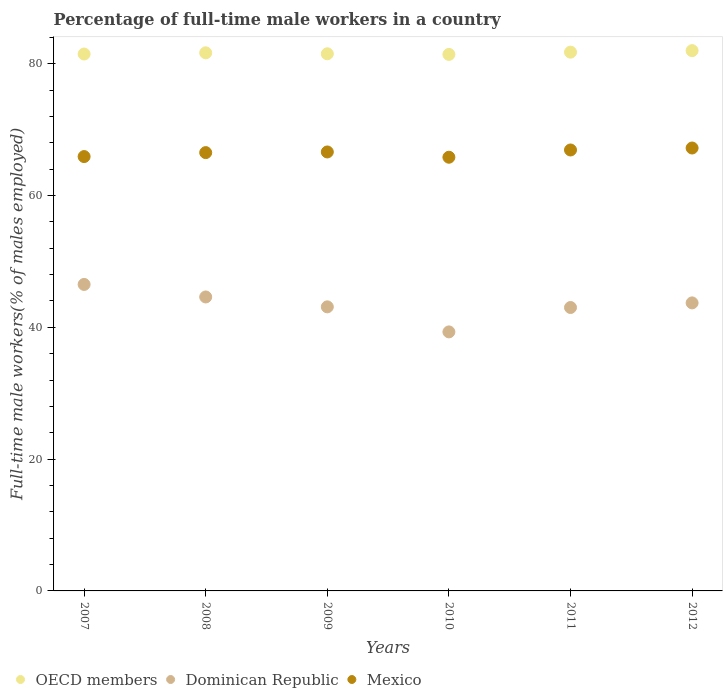How many different coloured dotlines are there?
Your response must be concise. 3. Across all years, what is the maximum percentage of full-time male workers in OECD members?
Offer a terse response. 81.97. Across all years, what is the minimum percentage of full-time male workers in Dominican Republic?
Provide a succinct answer. 39.3. What is the total percentage of full-time male workers in OECD members in the graph?
Give a very brief answer. 489.71. What is the difference between the percentage of full-time male workers in OECD members in 2008 and that in 2009?
Make the answer very short. 0.15. What is the difference between the percentage of full-time male workers in Mexico in 2008 and the percentage of full-time male workers in Dominican Republic in 2012?
Offer a terse response. 22.8. What is the average percentage of full-time male workers in Mexico per year?
Ensure brevity in your answer.  66.48. In the year 2008, what is the difference between the percentage of full-time male workers in Mexico and percentage of full-time male workers in Dominican Republic?
Ensure brevity in your answer.  21.9. What is the ratio of the percentage of full-time male workers in OECD members in 2008 to that in 2009?
Offer a terse response. 1. Is the percentage of full-time male workers in Mexico in 2009 less than that in 2010?
Keep it short and to the point. No. Is the difference between the percentage of full-time male workers in Mexico in 2007 and 2012 greater than the difference between the percentage of full-time male workers in Dominican Republic in 2007 and 2012?
Provide a short and direct response. No. What is the difference between the highest and the second highest percentage of full-time male workers in Dominican Republic?
Make the answer very short. 1.9. What is the difference between the highest and the lowest percentage of full-time male workers in Mexico?
Make the answer very short. 1.4. In how many years, is the percentage of full-time male workers in OECD members greater than the average percentage of full-time male workers in OECD members taken over all years?
Offer a very short reply. 3. Is the sum of the percentage of full-time male workers in OECD members in 2007 and 2009 greater than the maximum percentage of full-time male workers in Dominican Republic across all years?
Provide a short and direct response. Yes. Is it the case that in every year, the sum of the percentage of full-time male workers in Mexico and percentage of full-time male workers in Dominican Republic  is greater than the percentage of full-time male workers in OECD members?
Provide a succinct answer. Yes. How many years are there in the graph?
Offer a terse response. 6. Are the values on the major ticks of Y-axis written in scientific E-notation?
Your answer should be very brief. No. How are the legend labels stacked?
Make the answer very short. Horizontal. What is the title of the graph?
Provide a succinct answer. Percentage of full-time male workers in a country. What is the label or title of the Y-axis?
Provide a succinct answer. Full-time male workers(% of males employed). What is the Full-time male workers(% of males employed) in OECD members in 2007?
Your response must be concise. 81.46. What is the Full-time male workers(% of males employed) of Dominican Republic in 2007?
Your answer should be compact. 46.5. What is the Full-time male workers(% of males employed) in Mexico in 2007?
Provide a succinct answer. 65.9. What is the Full-time male workers(% of males employed) in OECD members in 2008?
Offer a terse response. 81.64. What is the Full-time male workers(% of males employed) of Dominican Republic in 2008?
Ensure brevity in your answer.  44.6. What is the Full-time male workers(% of males employed) of Mexico in 2008?
Offer a very short reply. 66.5. What is the Full-time male workers(% of males employed) in OECD members in 2009?
Ensure brevity in your answer.  81.49. What is the Full-time male workers(% of males employed) of Dominican Republic in 2009?
Your answer should be very brief. 43.1. What is the Full-time male workers(% of males employed) in Mexico in 2009?
Your answer should be compact. 66.6. What is the Full-time male workers(% of males employed) in OECD members in 2010?
Your answer should be compact. 81.4. What is the Full-time male workers(% of males employed) of Dominican Republic in 2010?
Offer a terse response. 39.3. What is the Full-time male workers(% of males employed) in Mexico in 2010?
Ensure brevity in your answer.  65.8. What is the Full-time male workers(% of males employed) of OECD members in 2011?
Provide a short and direct response. 81.74. What is the Full-time male workers(% of males employed) of Dominican Republic in 2011?
Your response must be concise. 43. What is the Full-time male workers(% of males employed) of Mexico in 2011?
Give a very brief answer. 66.9. What is the Full-time male workers(% of males employed) in OECD members in 2012?
Provide a succinct answer. 81.97. What is the Full-time male workers(% of males employed) of Dominican Republic in 2012?
Offer a terse response. 43.7. What is the Full-time male workers(% of males employed) of Mexico in 2012?
Offer a very short reply. 67.2. Across all years, what is the maximum Full-time male workers(% of males employed) in OECD members?
Your response must be concise. 81.97. Across all years, what is the maximum Full-time male workers(% of males employed) in Dominican Republic?
Your response must be concise. 46.5. Across all years, what is the maximum Full-time male workers(% of males employed) of Mexico?
Offer a terse response. 67.2. Across all years, what is the minimum Full-time male workers(% of males employed) of OECD members?
Ensure brevity in your answer.  81.4. Across all years, what is the minimum Full-time male workers(% of males employed) in Dominican Republic?
Make the answer very short. 39.3. Across all years, what is the minimum Full-time male workers(% of males employed) in Mexico?
Provide a short and direct response. 65.8. What is the total Full-time male workers(% of males employed) of OECD members in the graph?
Give a very brief answer. 489.71. What is the total Full-time male workers(% of males employed) in Dominican Republic in the graph?
Offer a very short reply. 260.2. What is the total Full-time male workers(% of males employed) of Mexico in the graph?
Keep it short and to the point. 398.9. What is the difference between the Full-time male workers(% of males employed) of OECD members in 2007 and that in 2008?
Offer a very short reply. -0.19. What is the difference between the Full-time male workers(% of males employed) in Dominican Republic in 2007 and that in 2008?
Provide a succinct answer. 1.9. What is the difference between the Full-time male workers(% of males employed) in OECD members in 2007 and that in 2009?
Offer a very short reply. -0.04. What is the difference between the Full-time male workers(% of males employed) in Dominican Republic in 2007 and that in 2009?
Give a very brief answer. 3.4. What is the difference between the Full-time male workers(% of males employed) of OECD members in 2007 and that in 2010?
Provide a succinct answer. 0.06. What is the difference between the Full-time male workers(% of males employed) in Mexico in 2007 and that in 2010?
Make the answer very short. 0.1. What is the difference between the Full-time male workers(% of males employed) of OECD members in 2007 and that in 2011?
Provide a short and direct response. -0.29. What is the difference between the Full-time male workers(% of males employed) in Dominican Republic in 2007 and that in 2011?
Offer a terse response. 3.5. What is the difference between the Full-time male workers(% of males employed) in OECD members in 2007 and that in 2012?
Your response must be concise. -0.52. What is the difference between the Full-time male workers(% of males employed) in Dominican Republic in 2007 and that in 2012?
Your answer should be compact. 2.8. What is the difference between the Full-time male workers(% of males employed) of Mexico in 2007 and that in 2012?
Ensure brevity in your answer.  -1.3. What is the difference between the Full-time male workers(% of males employed) of OECD members in 2008 and that in 2009?
Your answer should be very brief. 0.15. What is the difference between the Full-time male workers(% of males employed) of Dominican Republic in 2008 and that in 2009?
Your response must be concise. 1.5. What is the difference between the Full-time male workers(% of males employed) of Mexico in 2008 and that in 2009?
Ensure brevity in your answer.  -0.1. What is the difference between the Full-time male workers(% of males employed) of OECD members in 2008 and that in 2010?
Your answer should be compact. 0.24. What is the difference between the Full-time male workers(% of males employed) in Dominican Republic in 2008 and that in 2010?
Keep it short and to the point. 5.3. What is the difference between the Full-time male workers(% of males employed) of Mexico in 2008 and that in 2010?
Make the answer very short. 0.7. What is the difference between the Full-time male workers(% of males employed) in OECD members in 2008 and that in 2011?
Keep it short and to the point. -0.1. What is the difference between the Full-time male workers(% of males employed) in Dominican Republic in 2008 and that in 2011?
Provide a succinct answer. 1.6. What is the difference between the Full-time male workers(% of males employed) of OECD members in 2008 and that in 2012?
Keep it short and to the point. -0.33. What is the difference between the Full-time male workers(% of males employed) of Dominican Republic in 2008 and that in 2012?
Your answer should be very brief. 0.9. What is the difference between the Full-time male workers(% of males employed) of OECD members in 2009 and that in 2010?
Keep it short and to the point. 0.09. What is the difference between the Full-time male workers(% of males employed) of OECD members in 2009 and that in 2011?
Ensure brevity in your answer.  -0.25. What is the difference between the Full-time male workers(% of males employed) in Mexico in 2009 and that in 2011?
Provide a succinct answer. -0.3. What is the difference between the Full-time male workers(% of males employed) in OECD members in 2009 and that in 2012?
Offer a very short reply. -0.48. What is the difference between the Full-time male workers(% of males employed) in Dominican Republic in 2009 and that in 2012?
Provide a short and direct response. -0.6. What is the difference between the Full-time male workers(% of males employed) in Mexico in 2009 and that in 2012?
Offer a terse response. -0.6. What is the difference between the Full-time male workers(% of males employed) of OECD members in 2010 and that in 2011?
Make the answer very short. -0.34. What is the difference between the Full-time male workers(% of males employed) in Mexico in 2010 and that in 2011?
Provide a short and direct response. -1.1. What is the difference between the Full-time male workers(% of males employed) of OECD members in 2010 and that in 2012?
Provide a succinct answer. -0.57. What is the difference between the Full-time male workers(% of males employed) of Mexico in 2010 and that in 2012?
Provide a succinct answer. -1.4. What is the difference between the Full-time male workers(% of males employed) of OECD members in 2011 and that in 2012?
Provide a short and direct response. -0.23. What is the difference between the Full-time male workers(% of males employed) in OECD members in 2007 and the Full-time male workers(% of males employed) in Dominican Republic in 2008?
Provide a short and direct response. 36.86. What is the difference between the Full-time male workers(% of males employed) of OECD members in 2007 and the Full-time male workers(% of males employed) of Mexico in 2008?
Your answer should be very brief. 14.96. What is the difference between the Full-time male workers(% of males employed) of Dominican Republic in 2007 and the Full-time male workers(% of males employed) of Mexico in 2008?
Keep it short and to the point. -20. What is the difference between the Full-time male workers(% of males employed) of OECD members in 2007 and the Full-time male workers(% of males employed) of Dominican Republic in 2009?
Provide a succinct answer. 38.36. What is the difference between the Full-time male workers(% of males employed) in OECD members in 2007 and the Full-time male workers(% of males employed) in Mexico in 2009?
Your response must be concise. 14.86. What is the difference between the Full-time male workers(% of males employed) in Dominican Republic in 2007 and the Full-time male workers(% of males employed) in Mexico in 2009?
Offer a terse response. -20.1. What is the difference between the Full-time male workers(% of males employed) of OECD members in 2007 and the Full-time male workers(% of males employed) of Dominican Republic in 2010?
Your answer should be compact. 42.16. What is the difference between the Full-time male workers(% of males employed) of OECD members in 2007 and the Full-time male workers(% of males employed) of Mexico in 2010?
Provide a short and direct response. 15.66. What is the difference between the Full-time male workers(% of males employed) of Dominican Republic in 2007 and the Full-time male workers(% of males employed) of Mexico in 2010?
Offer a very short reply. -19.3. What is the difference between the Full-time male workers(% of males employed) of OECD members in 2007 and the Full-time male workers(% of males employed) of Dominican Republic in 2011?
Make the answer very short. 38.46. What is the difference between the Full-time male workers(% of males employed) in OECD members in 2007 and the Full-time male workers(% of males employed) in Mexico in 2011?
Ensure brevity in your answer.  14.56. What is the difference between the Full-time male workers(% of males employed) of Dominican Republic in 2007 and the Full-time male workers(% of males employed) of Mexico in 2011?
Ensure brevity in your answer.  -20.4. What is the difference between the Full-time male workers(% of males employed) of OECD members in 2007 and the Full-time male workers(% of males employed) of Dominican Republic in 2012?
Provide a short and direct response. 37.76. What is the difference between the Full-time male workers(% of males employed) of OECD members in 2007 and the Full-time male workers(% of males employed) of Mexico in 2012?
Ensure brevity in your answer.  14.26. What is the difference between the Full-time male workers(% of males employed) of Dominican Republic in 2007 and the Full-time male workers(% of males employed) of Mexico in 2012?
Your answer should be very brief. -20.7. What is the difference between the Full-time male workers(% of males employed) of OECD members in 2008 and the Full-time male workers(% of males employed) of Dominican Republic in 2009?
Ensure brevity in your answer.  38.54. What is the difference between the Full-time male workers(% of males employed) in OECD members in 2008 and the Full-time male workers(% of males employed) in Mexico in 2009?
Provide a succinct answer. 15.04. What is the difference between the Full-time male workers(% of males employed) of Dominican Republic in 2008 and the Full-time male workers(% of males employed) of Mexico in 2009?
Your answer should be compact. -22. What is the difference between the Full-time male workers(% of males employed) in OECD members in 2008 and the Full-time male workers(% of males employed) in Dominican Republic in 2010?
Provide a succinct answer. 42.34. What is the difference between the Full-time male workers(% of males employed) in OECD members in 2008 and the Full-time male workers(% of males employed) in Mexico in 2010?
Your answer should be very brief. 15.84. What is the difference between the Full-time male workers(% of males employed) of Dominican Republic in 2008 and the Full-time male workers(% of males employed) of Mexico in 2010?
Provide a short and direct response. -21.2. What is the difference between the Full-time male workers(% of males employed) of OECD members in 2008 and the Full-time male workers(% of males employed) of Dominican Republic in 2011?
Make the answer very short. 38.64. What is the difference between the Full-time male workers(% of males employed) in OECD members in 2008 and the Full-time male workers(% of males employed) in Mexico in 2011?
Ensure brevity in your answer.  14.74. What is the difference between the Full-time male workers(% of males employed) of Dominican Republic in 2008 and the Full-time male workers(% of males employed) of Mexico in 2011?
Provide a short and direct response. -22.3. What is the difference between the Full-time male workers(% of males employed) in OECD members in 2008 and the Full-time male workers(% of males employed) in Dominican Republic in 2012?
Offer a terse response. 37.94. What is the difference between the Full-time male workers(% of males employed) in OECD members in 2008 and the Full-time male workers(% of males employed) in Mexico in 2012?
Give a very brief answer. 14.44. What is the difference between the Full-time male workers(% of males employed) in Dominican Republic in 2008 and the Full-time male workers(% of males employed) in Mexico in 2012?
Offer a very short reply. -22.6. What is the difference between the Full-time male workers(% of males employed) of OECD members in 2009 and the Full-time male workers(% of males employed) of Dominican Republic in 2010?
Offer a terse response. 42.19. What is the difference between the Full-time male workers(% of males employed) of OECD members in 2009 and the Full-time male workers(% of males employed) of Mexico in 2010?
Keep it short and to the point. 15.69. What is the difference between the Full-time male workers(% of males employed) in Dominican Republic in 2009 and the Full-time male workers(% of males employed) in Mexico in 2010?
Ensure brevity in your answer.  -22.7. What is the difference between the Full-time male workers(% of males employed) of OECD members in 2009 and the Full-time male workers(% of males employed) of Dominican Republic in 2011?
Make the answer very short. 38.49. What is the difference between the Full-time male workers(% of males employed) of OECD members in 2009 and the Full-time male workers(% of males employed) of Mexico in 2011?
Your answer should be very brief. 14.59. What is the difference between the Full-time male workers(% of males employed) in Dominican Republic in 2009 and the Full-time male workers(% of males employed) in Mexico in 2011?
Keep it short and to the point. -23.8. What is the difference between the Full-time male workers(% of males employed) in OECD members in 2009 and the Full-time male workers(% of males employed) in Dominican Republic in 2012?
Give a very brief answer. 37.79. What is the difference between the Full-time male workers(% of males employed) of OECD members in 2009 and the Full-time male workers(% of males employed) of Mexico in 2012?
Offer a very short reply. 14.29. What is the difference between the Full-time male workers(% of males employed) of Dominican Republic in 2009 and the Full-time male workers(% of males employed) of Mexico in 2012?
Give a very brief answer. -24.1. What is the difference between the Full-time male workers(% of males employed) of OECD members in 2010 and the Full-time male workers(% of males employed) of Dominican Republic in 2011?
Give a very brief answer. 38.4. What is the difference between the Full-time male workers(% of males employed) of OECD members in 2010 and the Full-time male workers(% of males employed) of Mexico in 2011?
Provide a short and direct response. 14.5. What is the difference between the Full-time male workers(% of males employed) of Dominican Republic in 2010 and the Full-time male workers(% of males employed) of Mexico in 2011?
Your response must be concise. -27.6. What is the difference between the Full-time male workers(% of males employed) of OECD members in 2010 and the Full-time male workers(% of males employed) of Dominican Republic in 2012?
Ensure brevity in your answer.  37.7. What is the difference between the Full-time male workers(% of males employed) in OECD members in 2010 and the Full-time male workers(% of males employed) in Mexico in 2012?
Provide a short and direct response. 14.2. What is the difference between the Full-time male workers(% of males employed) of Dominican Republic in 2010 and the Full-time male workers(% of males employed) of Mexico in 2012?
Your response must be concise. -27.9. What is the difference between the Full-time male workers(% of males employed) of OECD members in 2011 and the Full-time male workers(% of males employed) of Dominican Republic in 2012?
Ensure brevity in your answer.  38.04. What is the difference between the Full-time male workers(% of males employed) of OECD members in 2011 and the Full-time male workers(% of males employed) of Mexico in 2012?
Offer a terse response. 14.54. What is the difference between the Full-time male workers(% of males employed) of Dominican Republic in 2011 and the Full-time male workers(% of males employed) of Mexico in 2012?
Provide a short and direct response. -24.2. What is the average Full-time male workers(% of males employed) in OECD members per year?
Ensure brevity in your answer.  81.62. What is the average Full-time male workers(% of males employed) in Dominican Republic per year?
Provide a short and direct response. 43.37. What is the average Full-time male workers(% of males employed) of Mexico per year?
Provide a succinct answer. 66.48. In the year 2007, what is the difference between the Full-time male workers(% of males employed) of OECD members and Full-time male workers(% of males employed) of Dominican Republic?
Your answer should be very brief. 34.96. In the year 2007, what is the difference between the Full-time male workers(% of males employed) of OECD members and Full-time male workers(% of males employed) of Mexico?
Provide a short and direct response. 15.56. In the year 2007, what is the difference between the Full-time male workers(% of males employed) in Dominican Republic and Full-time male workers(% of males employed) in Mexico?
Give a very brief answer. -19.4. In the year 2008, what is the difference between the Full-time male workers(% of males employed) of OECD members and Full-time male workers(% of males employed) of Dominican Republic?
Offer a terse response. 37.04. In the year 2008, what is the difference between the Full-time male workers(% of males employed) of OECD members and Full-time male workers(% of males employed) of Mexico?
Keep it short and to the point. 15.14. In the year 2008, what is the difference between the Full-time male workers(% of males employed) of Dominican Republic and Full-time male workers(% of males employed) of Mexico?
Ensure brevity in your answer.  -21.9. In the year 2009, what is the difference between the Full-time male workers(% of males employed) in OECD members and Full-time male workers(% of males employed) in Dominican Republic?
Your response must be concise. 38.39. In the year 2009, what is the difference between the Full-time male workers(% of males employed) in OECD members and Full-time male workers(% of males employed) in Mexico?
Your answer should be compact. 14.89. In the year 2009, what is the difference between the Full-time male workers(% of males employed) of Dominican Republic and Full-time male workers(% of males employed) of Mexico?
Ensure brevity in your answer.  -23.5. In the year 2010, what is the difference between the Full-time male workers(% of males employed) in OECD members and Full-time male workers(% of males employed) in Dominican Republic?
Offer a very short reply. 42.1. In the year 2010, what is the difference between the Full-time male workers(% of males employed) in OECD members and Full-time male workers(% of males employed) in Mexico?
Provide a succinct answer. 15.6. In the year 2010, what is the difference between the Full-time male workers(% of males employed) in Dominican Republic and Full-time male workers(% of males employed) in Mexico?
Keep it short and to the point. -26.5. In the year 2011, what is the difference between the Full-time male workers(% of males employed) of OECD members and Full-time male workers(% of males employed) of Dominican Republic?
Offer a very short reply. 38.74. In the year 2011, what is the difference between the Full-time male workers(% of males employed) of OECD members and Full-time male workers(% of males employed) of Mexico?
Your answer should be very brief. 14.84. In the year 2011, what is the difference between the Full-time male workers(% of males employed) of Dominican Republic and Full-time male workers(% of males employed) of Mexico?
Your response must be concise. -23.9. In the year 2012, what is the difference between the Full-time male workers(% of males employed) in OECD members and Full-time male workers(% of males employed) in Dominican Republic?
Ensure brevity in your answer.  38.27. In the year 2012, what is the difference between the Full-time male workers(% of males employed) in OECD members and Full-time male workers(% of males employed) in Mexico?
Keep it short and to the point. 14.77. In the year 2012, what is the difference between the Full-time male workers(% of males employed) of Dominican Republic and Full-time male workers(% of males employed) of Mexico?
Your response must be concise. -23.5. What is the ratio of the Full-time male workers(% of males employed) of Dominican Republic in 2007 to that in 2008?
Offer a terse response. 1.04. What is the ratio of the Full-time male workers(% of males employed) in OECD members in 2007 to that in 2009?
Ensure brevity in your answer.  1. What is the ratio of the Full-time male workers(% of males employed) of Dominican Republic in 2007 to that in 2009?
Offer a terse response. 1.08. What is the ratio of the Full-time male workers(% of males employed) of Dominican Republic in 2007 to that in 2010?
Offer a terse response. 1.18. What is the ratio of the Full-time male workers(% of males employed) in Mexico in 2007 to that in 2010?
Your answer should be very brief. 1. What is the ratio of the Full-time male workers(% of males employed) in Dominican Republic in 2007 to that in 2011?
Ensure brevity in your answer.  1.08. What is the ratio of the Full-time male workers(% of males employed) of Mexico in 2007 to that in 2011?
Offer a very short reply. 0.99. What is the ratio of the Full-time male workers(% of males employed) in OECD members in 2007 to that in 2012?
Your answer should be very brief. 0.99. What is the ratio of the Full-time male workers(% of males employed) in Dominican Republic in 2007 to that in 2012?
Your response must be concise. 1.06. What is the ratio of the Full-time male workers(% of males employed) of Mexico in 2007 to that in 2012?
Your answer should be compact. 0.98. What is the ratio of the Full-time male workers(% of males employed) in Dominican Republic in 2008 to that in 2009?
Make the answer very short. 1.03. What is the ratio of the Full-time male workers(% of males employed) of OECD members in 2008 to that in 2010?
Your answer should be compact. 1. What is the ratio of the Full-time male workers(% of males employed) in Dominican Republic in 2008 to that in 2010?
Give a very brief answer. 1.13. What is the ratio of the Full-time male workers(% of males employed) of Mexico in 2008 to that in 2010?
Keep it short and to the point. 1.01. What is the ratio of the Full-time male workers(% of males employed) in Dominican Republic in 2008 to that in 2011?
Keep it short and to the point. 1.04. What is the ratio of the Full-time male workers(% of males employed) of Dominican Republic in 2008 to that in 2012?
Your answer should be very brief. 1.02. What is the ratio of the Full-time male workers(% of males employed) in Mexico in 2008 to that in 2012?
Offer a terse response. 0.99. What is the ratio of the Full-time male workers(% of males employed) in OECD members in 2009 to that in 2010?
Give a very brief answer. 1. What is the ratio of the Full-time male workers(% of males employed) in Dominican Republic in 2009 to that in 2010?
Your answer should be compact. 1.1. What is the ratio of the Full-time male workers(% of males employed) in Mexico in 2009 to that in 2010?
Provide a short and direct response. 1.01. What is the ratio of the Full-time male workers(% of males employed) of OECD members in 2009 to that in 2011?
Your response must be concise. 1. What is the ratio of the Full-time male workers(% of males employed) in OECD members in 2009 to that in 2012?
Give a very brief answer. 0.99. What is the ratio of the Full-time male workers(% of males employed) of Dominican Republic in 2009 to that in 2012?
Ensure brevity in your answer.  0.99. What is the ratio of the Full-time male workers(% of males employed) of Dominican Republic in 2010 to that in 2011?
Your answer should be very brief. 0.91. What is the ratio of the Full-time male workers(% of males employed) in Mexico in 2010 to that in 2011?
Your answer should be very brief. 0.98. What is the ratio of the Full-time male workers(% of males employed) in Dominican Republic in 2010 to that in 2012?
Make the answer very short. 0.9. What is the ratio of the Full-time male workers(% of males employed) of Mexico in 2010 to that in 2012?
Your answer should be very brief. 0.98. What is the ratio of the Full-time male workers(% of males employed) of OECD members in 2011 to that in 2012?
Make the answer very short. 1. What is the ratio of the Full-time male workers(% of males employed) of Dominican Republic in 2011 to that in 2012?
Offer a terse response. 0.98. What is the ratio of the Full-time male workers(% of males employed) in Mexico in 2011 to that in 2012?
Offer a terse response. 1. What is the difference between the highest and the second highest Full-time male workers(% of males employed) of OECD members?
Make the answer very short. 0.23. What is the difference between the highest and the second highest Full-time male workers(% of males employed) in Dominican Republic?
Offer a terse response. 1.9. What is the difference between the highest and the second highest Full-time male workers(% of males employed) of Mexico?
Provide a short and direct response. 0.3. What is the difference between the highest and the lowest Full-time male workers(% of males employed) in OECD members?
Provide a succinct answer. 0.57. What is the difference between the highest and the lowest Full-time male workers(% of males employed) in Dominican Republic?
Provide a short and direct response. 7.2. What is the difference between the highest and the lowest Full-time male workers(% of males employed) of Mexico?
Your response must be concise. 1.4. 